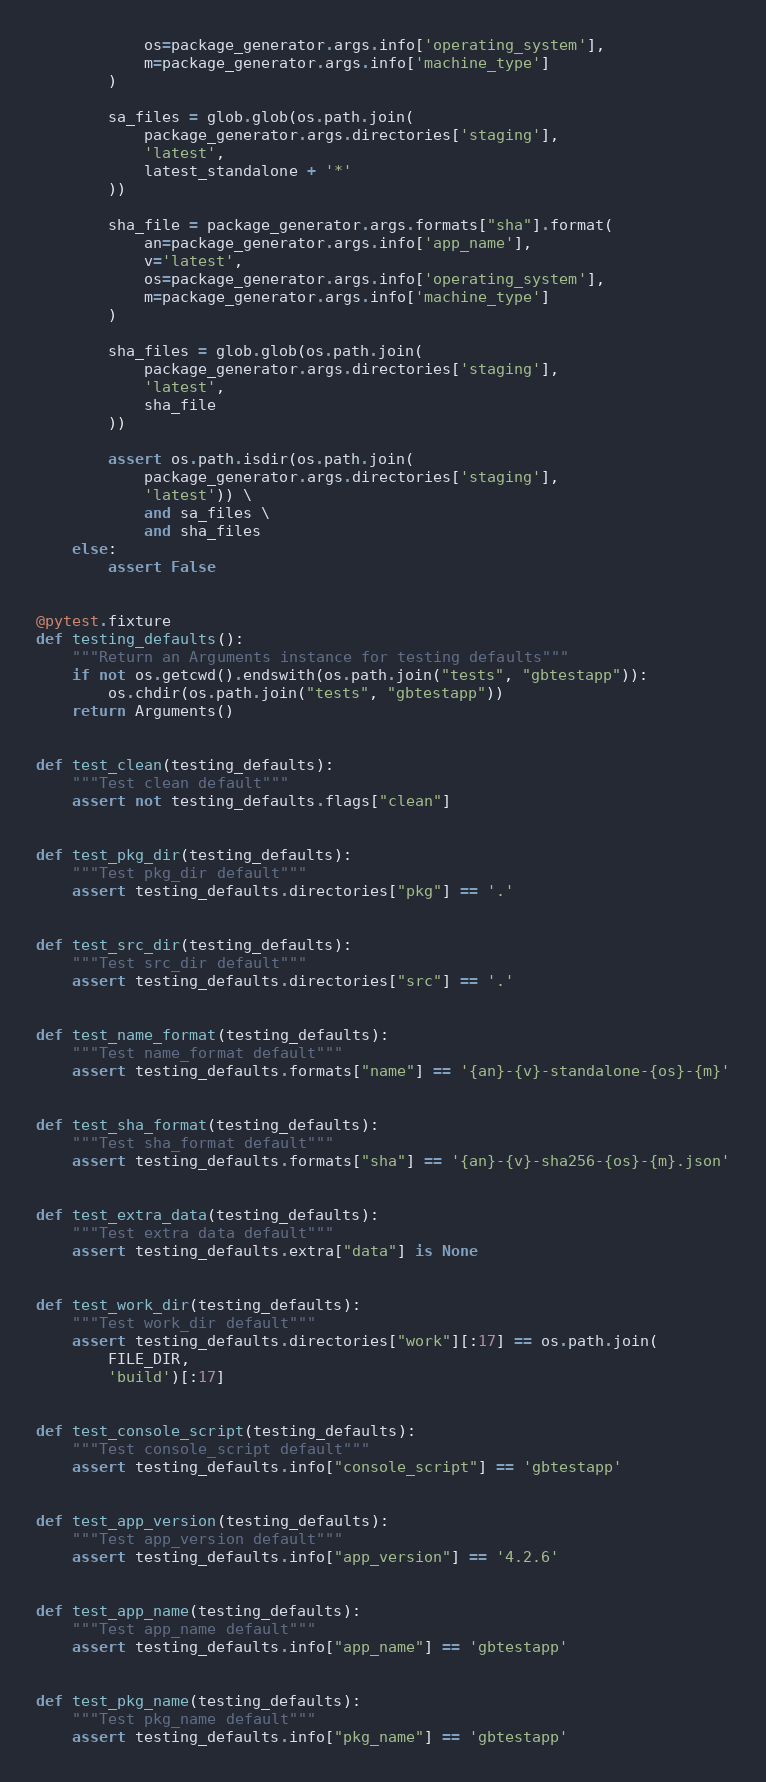<code> <loc_0><loc_0><loc_500><loc_500><_Python_>            os=package_generator.args.info['operating_system'],
            m=package_generator.args.info['machine_type']
        )

        sa_files = glob.glob(os.path.join(
            package_generator.args.directories['staging'],
            'latest',
            latest_standalone + '*'
        ))

        sha_file = package_generator.args.formats["sha"].format(
            an=package_generator.args.info['app_name'],
            v='latest',
            os=package_generator.args.info['operating_system'],
            m=package_generator.args.info['machine_type']
        )

        sha_files = glob.glob(os.path.join(
            package_generator.args.directories['staging'],
            'latest',
            sha_file
        ))

        assert os.path.isdir(os.path.join(
            package_generator.args.directories['staging'],
            'latest')) \
            and sa_files \
            and sha_files
    else:
        assert False


@pytest.fixture
def testing_defaults():
    """Return an Arguments instance for testing defaults"""
    if not os.getcwd().endswith(os.path.join("tests", "gbtestapp")):
        os.chdir(os.path.join("tests", "gbtestapp"))
    return Arguments()


def test_clean(testing_defaults):
    """Test clean default"""
    assert not testing_defaults.flags["clean"]


def test_pkg_dir(testing_defaults):
    """Test pkg_dir default"""
    assert testing_defaults.directories["pkg"] == '.'


def test_src_dir(testing_defaults):
    """Test src_dir default"""
    assert testing_defaults.directories["src"] == '.'


def test_name_format(testing_defaults):
    """Test name_format default"""
    assert testing_defaults.formats["name"] == '{an}-{v}-standalone-{os}-{m}'


def test_sha_format(testing_defaults):
    """Test sha_format default"""
    assert testing_defaults.formats["sha"] == '{an}-{v}-sha256-{os}-{m}.json'


def test_extra_data(testing_defaults):
    """Test extra data default"""
    assert testing_defaults.extra["data"] is None


def test_work_dir(testing_defaults):
    """Test work_dir default"""
    assert testing_defaults.directories["work"][:17] == os.path.join(
        FILE_DIR,
        'build')[:17]


def test_console_script(testing_defaults):
    """Test console_script default"""
    assert testing_defaults.info["console_script"] == 'gbtestapp'


def test_app_version(testing_defaults):
    """Test app_version default"""
    assert testing_defaults.info["app_version"] == '4.2.6'


def test_app_name(testing_defaults):
    """Test app_name default"""
    assert testing_defaults.info["app_name"] == 'gbtestapp'


def test_pkg_name(testing_defaults):
    """Test pkg_name default"""
    assert testing_defaults.info["pkg_name"] == 'gbtestapp'
</code> 